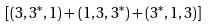<formula> <loc_0><loc_0><loc_500><loc_500>[ ( 3 , 3 ^ { * } , 1 ) + ( 1 , 3 , 3 ^ { * } ) + ( 3 ^ { * } , 1 , 3 ) ]</formula> 